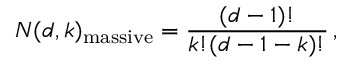Convert formula to latex. <formula><loc_0><loc_0><loc_500><loc_500>N ( d , k ) _ { m a s s i v e } = \frac { ( d - 1 ) ! } { k ! ( d - 1 - k ) ! } \, ,</formula> 